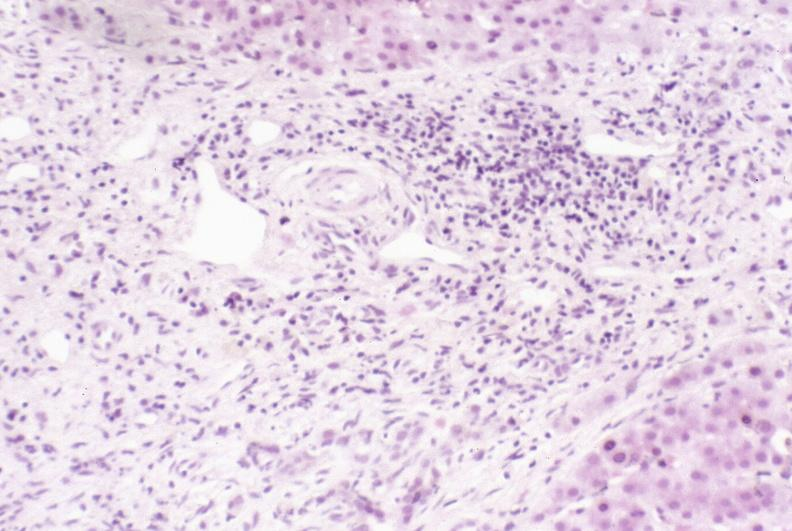s liver present?
Answer the question using a single word or phrase. Yes 